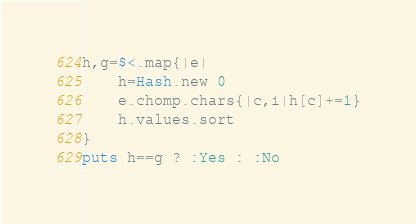Convert code to text. <code><loc_0><loc_0><loc_500><loc_500><_Ruby_>h,g=$<.map{|e|
	h=Hash.new 0
	e.chomp.chars{|c,i|h[c]+=1}
	h.values.sort
}
puts h==g ? :Yes : :No</code> 